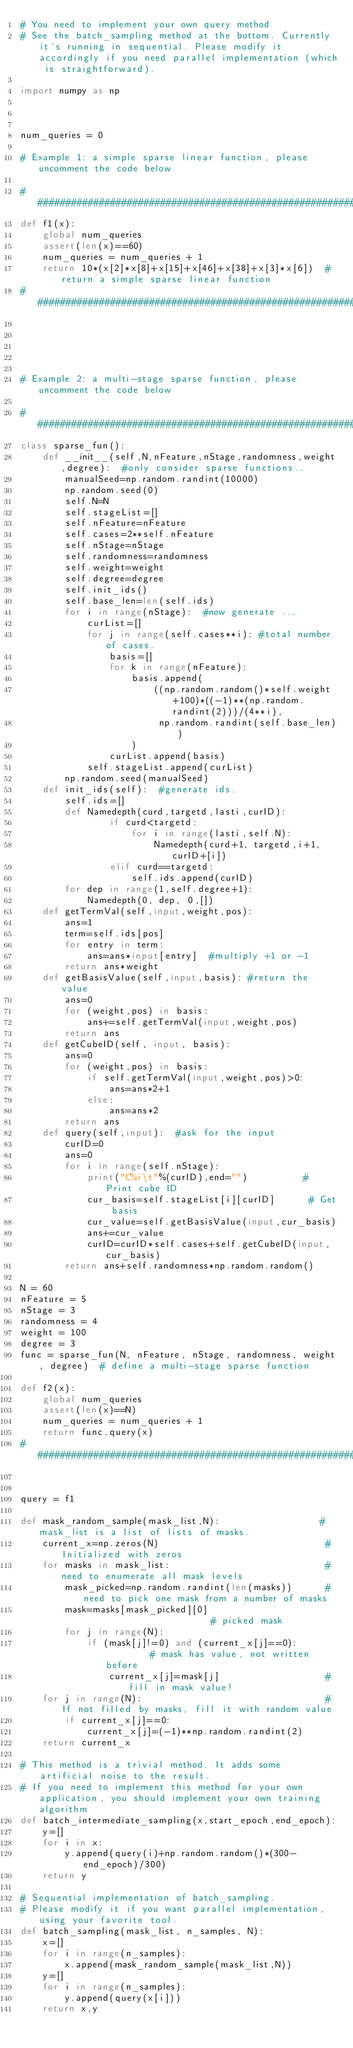<code> <loc_0><loc_0><loc_500><loc_500><_Python_># You need to implement your own query method
# See the batch_sampling method at the bottom. Currently it's running in sequential. Please modify it accordingly if you need parallel implementation (which is straightforward).

import numpy as np



num_queries = 0

# Example 1: a simple sparse linear function, please uncomment the code below

##########################################################################
def f1(x):
    global num_queries
    assert(len(x)==60)
    num_queries = num_queries + 1
    return 10*(x[2]*x[8]+x[15]+x[46]+x[38]+x[3]*x[6])  #return a simple sparse linear function
##########################################################################





# Example 2: a multi-stage sparse function, please uncomment the code below

#########################################################################
class sparse_fun():
    def __init__(self,N,nFeature,nStage,randomness,weight,degree):  #only consider sparse functions..
        manualSeed=np.random.randint(10000)
        np.random.seed(0)
        self.N=N
        self.stageList=[]
        self.nFeature=nFeature
        self.cases=2**self.nFeature
        self.nStage=nStage
        self.randomness=randomness
        self.weight=weight
        self.degree=degree
        self.init_ids()
        self.base_len=len(self.ids)
        for i in range(nStage):  #now generate ...
            curList=[]
            for j in range(self.cases**i): #total number of cases.
                basis=[]
                for k in range(nFeature):
                    basis.append(
                        ((np.random.random()*self.weight+100)*((-1)**(np.random.randint(2)))/(4**i),
                         np.random.randint(self.base_len))
                    )
                curList.append(basis)
            self.stageList.append(curList)
        np.random.seed(manualSeed)
    def init_ids(self):  #generate ids.
        self.ids=[]
        def Namedepth(curd,targetd,lasti,curID):
                if curd<targetd:
                    for i in range(lasti,self.N):
                        Namedepth(curd+1, targetd,i+1, curID+[i])
                elif curd==targetd:
                    self.ids.append(curID)
        for dep in range(1,self.degree+1):
            Namedepth(0, dep, 0,[])
    def getTermVal(self,input,weight,pos):
        ans=1
        term=self.ids[pos]
        for entry in term:
            ans=ans*input[entry]  #multiply +1 or -1
        return ans*weight
    def getBasisValue(self,input,basis): #return the value
        ans=0
        for (weight,pos) in basis:
            ans+=self.getTermVal(input,weight,pos)
        return ans
    def getCubeID(self, input, basis):
        ans=0
        for (weight,pos) in basis:
            if self.getTermVal(input,weight,pos)>0:
                ans=ans*2+1
            else:
                ans=ans*2
        return ans
    def query(self,input):  #ask for the input
        curID=0
        ans=0
        for i in range(self.nStage):
            print("C%i\t"%(curID),end="")          # Print cube ID
            cur_basis=self.stageList[i][curID]      # Get basis
            cur_value=self.getBasisValue(input,cur_basis)
            ans+=cur_value
            curID=curID*self.cases+self.getCubeID(input, cur_basis)
        return ans+self.randomness*np.random.random()

N = 60
nFeature = 5
nStage = 3
randomness = 4
weight = 100
degree = 3
func = sparse_fun(N, nFeature, nStage, randomness, weight, degree)  # define a multi-stage sparse function

def f2(x):
    global num_queries
    assert(len(x)==N)
    num_queries = num_queries + 1
    return func.query(x)
#########################################################################


query = f1

def mask_random_sample(mask_list,N):                  # mask_list is a list of lists of masks.
    current_x=np.zeros(N)                              # Initialized with zeros
    for masks in mask_list:                            # need to enumerate all mask levels
        mask_picked=np.random.randint(len(masks))      # need to pick one mask from a number of masks
        mask=masks[mask_picked][0]                        # picked mask
        for j in range(N):
            if (mask[j]!=0) and (current_x[j]==0):         # mask has value, not written before
                current_x[j]=mask[j]                   # fill in mask value!
    for j in range(N):                                 # If not filled by masks, fill it with random value
        if current_x[j]==0:
            current_x[j]=(-1)**np.random.randint(2)
    return current_x

# This method is a trivial method. It adds some artificial noise to the result.
# If you need to implement this method for your own application, you should implement your own training algorithm
def batch_intermediate_sampling(x,start_epoch,end_epoch):
    y=[]
    for i in x:
        y.append(query(i)+np.random.random()*(300-end_epoch)/300)
    return y

# Sequential implementation of batch_sampling.
# Please modify it if you want parallel implementation, using your favorite tool.
def batch_sampling(mask_list, n_samples, N):
    x=[]
    for i in range(n_samples):
        x.append(mask_random_sample(mask_list,N))
    y=[]
    for i in range(n_samples):
        y.append(query(x[i]))
    return x,y

</code> 